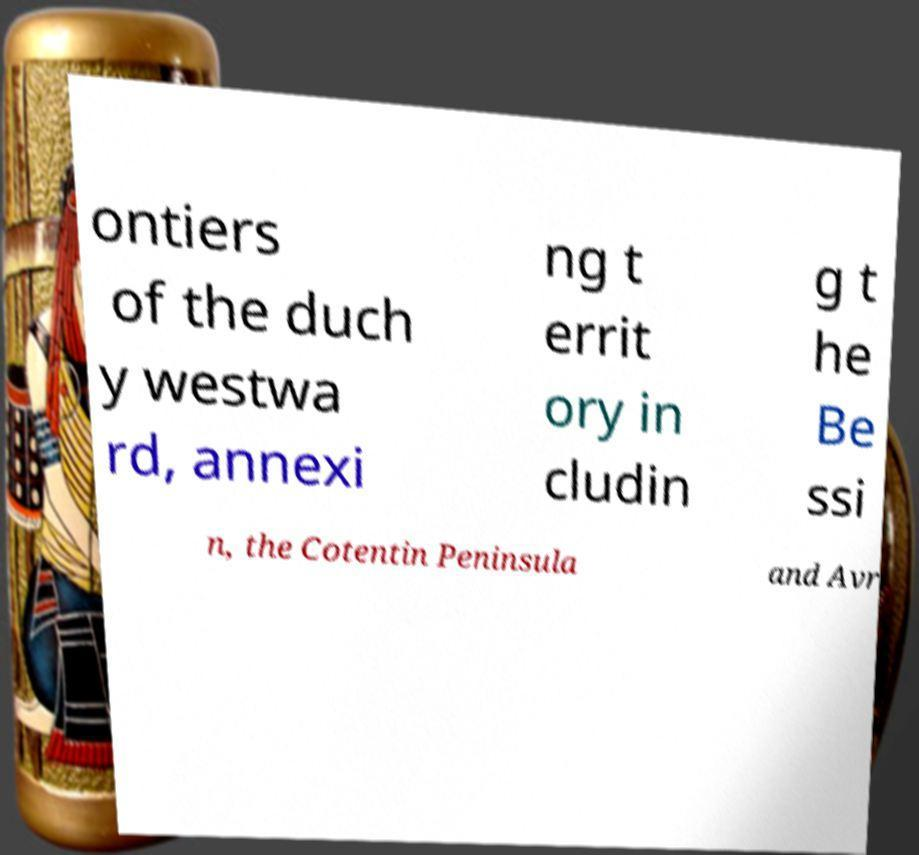Can you read and provide the text displayed in the image?This photo seems to have some interesting text. Can you extract and type it out for me? ontiers of the duch y westwa rd, annexi ng t errit ory in cludin g t he Be ssi n, the Cotentin Peninsula and Avr 